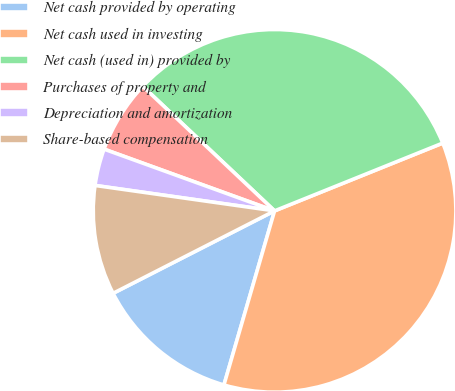Convert chart. <chart><loc_0><loc_0><loc_500><loc_500><pie_chart><fcel>Net cash provided by operating<fcel>Net cash used in investing<fcel>Net cash (used in) provided by<fcel>Purchases of property and<fcel>Depreciation and amortization<fcel>Share-based compensation<nl><fcel>12.98%<fcel>35.6%<fcel>31.85%<fcel>6.52%<fcel>3.29%<fcel>9.75%<nl></chart> 